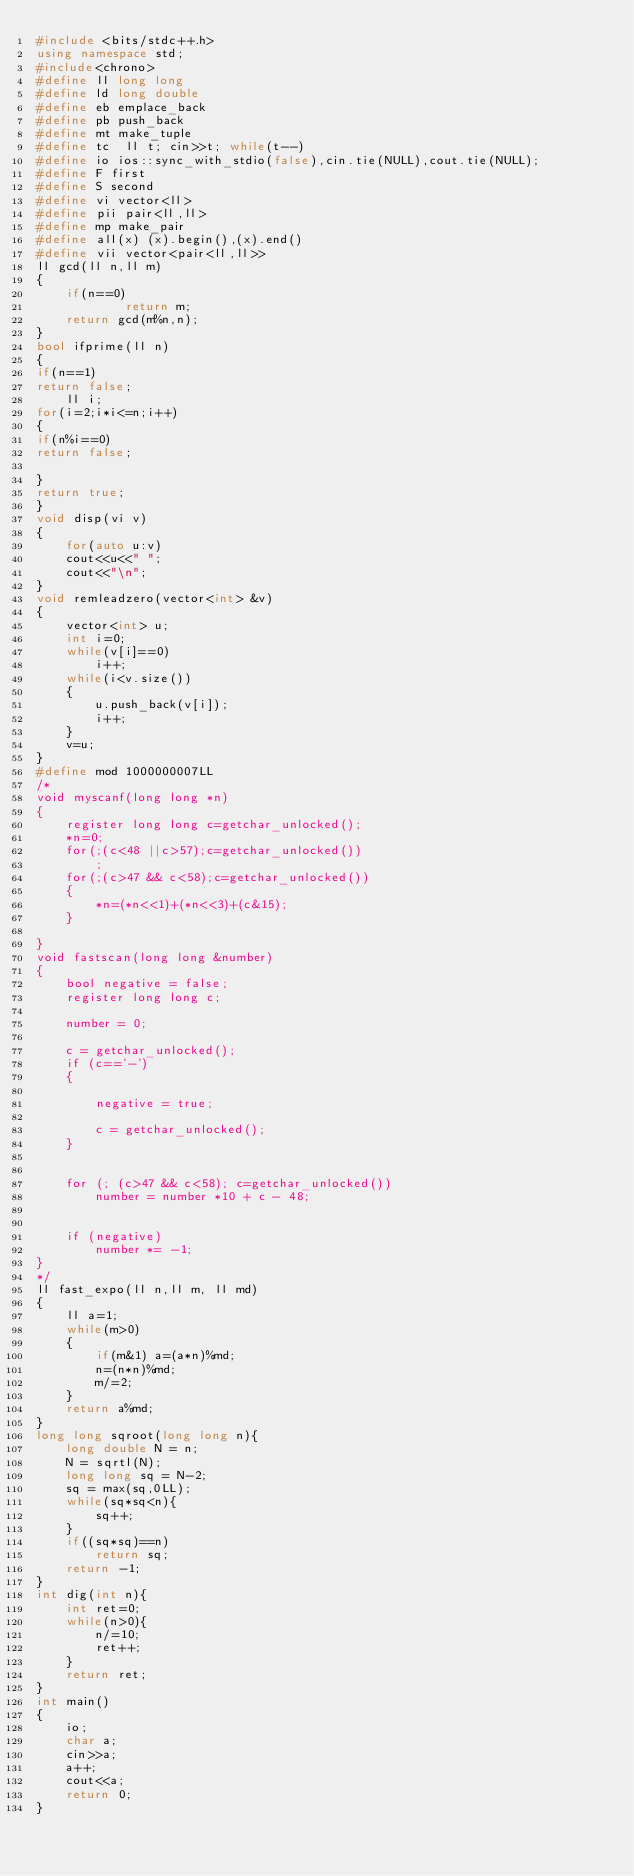Convert code to text. <code><loc_0><loc_0><loc_500><loc_500><_C++_>#include <bits/stdc++.h>
using namespace std;
#include<chrono>
#define ll long long
#define ld long double
#define eb emplace_back
#define pb push_back
#define mt make_tuple
#define tc  ll t; cin>>t; while(t--)
#define io ios::sync_with_stdio(false),cin.tie(NULL),cout.tie(NULL);
#define F first
#define S second
#define vi vector<ll>
#define pii pair<ll,ll>
#define mp make_pair
#define all(x) (x).begin(),(x).end()
#define vii vector<pair<ll,ll>>
ll gcd(ll n,ll m)
{
    if(n==0)
            return m;
    return gcd(m%n,n);
}
bool ifprime(ll n)
{
if(n==1)
return false;
    ll i;
for(i=2;i*i<=n;i++)
{
if(n%i==0)
return false;
 
}
return true;
}
void disp(vi v)
{
    for(auto u:v)
    cout<<u<<" ";
    cout<<"\n";
}
void remleadzero(vector<int> &v)
{
    vector<int> u;
    int i=0;
    while(v[i]==0)
        i++;
    while(i<v.size())
    {
        u.push_back(v[i]);
        i++;
    }
    v=u;
}
#define mod 1000000007LL
/*
void myscanf(long long *n)
{
    register long long c=getchar_unlocked();
    *n=0;
    for(;(c<48 ||c>57);c=getchar_unlocked())
        ;
    for(;(c>47 && c<58);c=getchar_unlocked())
    {
        *n=(*n<<1)+(*n<<3)+(c&15);
    }
 
}
void fastscan(long long &number)
{
    bool negative = false;
    register long long c;
 
    number = 0;
 
    c = getchar_unlocked();
    if (c=='-')
    {
 
        negative = true;
 
        c = getchar_unlocked();
    }
 
 
    for (; (c>47 && c<58); c=getchar_unlocked())
        number = number *10 + c - 48;
 
 
    if (negative)
        number *= -1;
}
*/
ll fast_expo(ll n,ll m, ll md)
{
    ll a=1;
    while(m>0)
    {
        if(m&1) a=(a*n)%md;
        n=(n*n)%md;
        m/=2;
    }
    return a%md;
}
long long sqroot(long long n){
    long double N = n;
    N = sqrtl(N);
    long long sq = N-2;
    sq = max(sq,0LL);
    while(sq*sq<n){
        sq++;
    } 
    if((sq*sq)==n)
        return sq;
    return -1;
}
int dig(int n){
    int ret=0;
    while(n>0){
        n/=10;
        ret++;
    }
    return ret;
}
int main()
{
    io;
    char a;
    cin>>a;
    a++;
    cout<<a;
    return 0;
}
</code> 